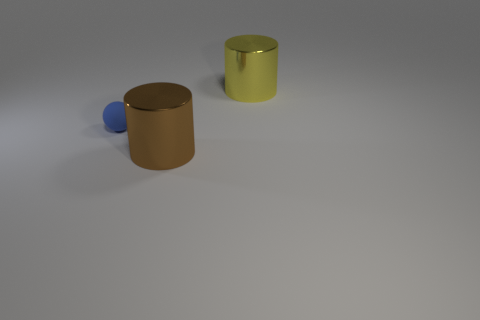The large object behind the brown thing in front of the blue rubber ball is what shape?
Provide a succinct answer. Cylinder. Are there any other things that are the same color as the small matte object?
Provide a short and direct response. No. There is a yellow metallic cylinder; is it the same size as the metal cylinder that is to the left of the yellow metallic thing?
Make the answer very short. Yes. How many large things are blue rubber spheres or brown cylinders?
Make the answer very short. 1. Are there more brown cylinders than large cyan shiny cubes?
Give a very brief answer. Yes. There is a shiny thing that is in front of the large object behind the small blue thing; what number of small blue matte things are on the right side of it?
Your answer should be very brief. 0. The yellow thing is what shape?
Make the answer very short. Cylinder. What number of other objects are there of the same material as the brown thing?
Provide a succinct answer. 1. Is the size of the brown shiny cylinder the same as the blue sphere?
Your response must be concise. No. There is a large metal thing in front of the yellow thing; what shape is it?
Provide a short and direct response. Cylinder. 